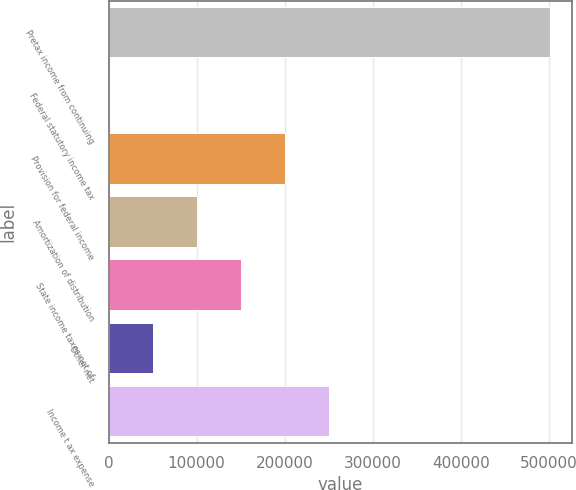Convert chart to OTSL. <chart><loc_0><loc_0><loc_500><loc_500><bar_chart><fcel>Pretax income from continuing<fcel>Federal statutory income tax<fcel>Provision for federal income<fcel>Amortization of distribution<fcel>State income taxes net of<fcel>Other net<fcel>Income t ax expense<nl><fcel>500441<fcel>35<fcel>200197<fcel>100116<fcel>150157<fcel>50075.6<fcel>250238<nl></chart> 